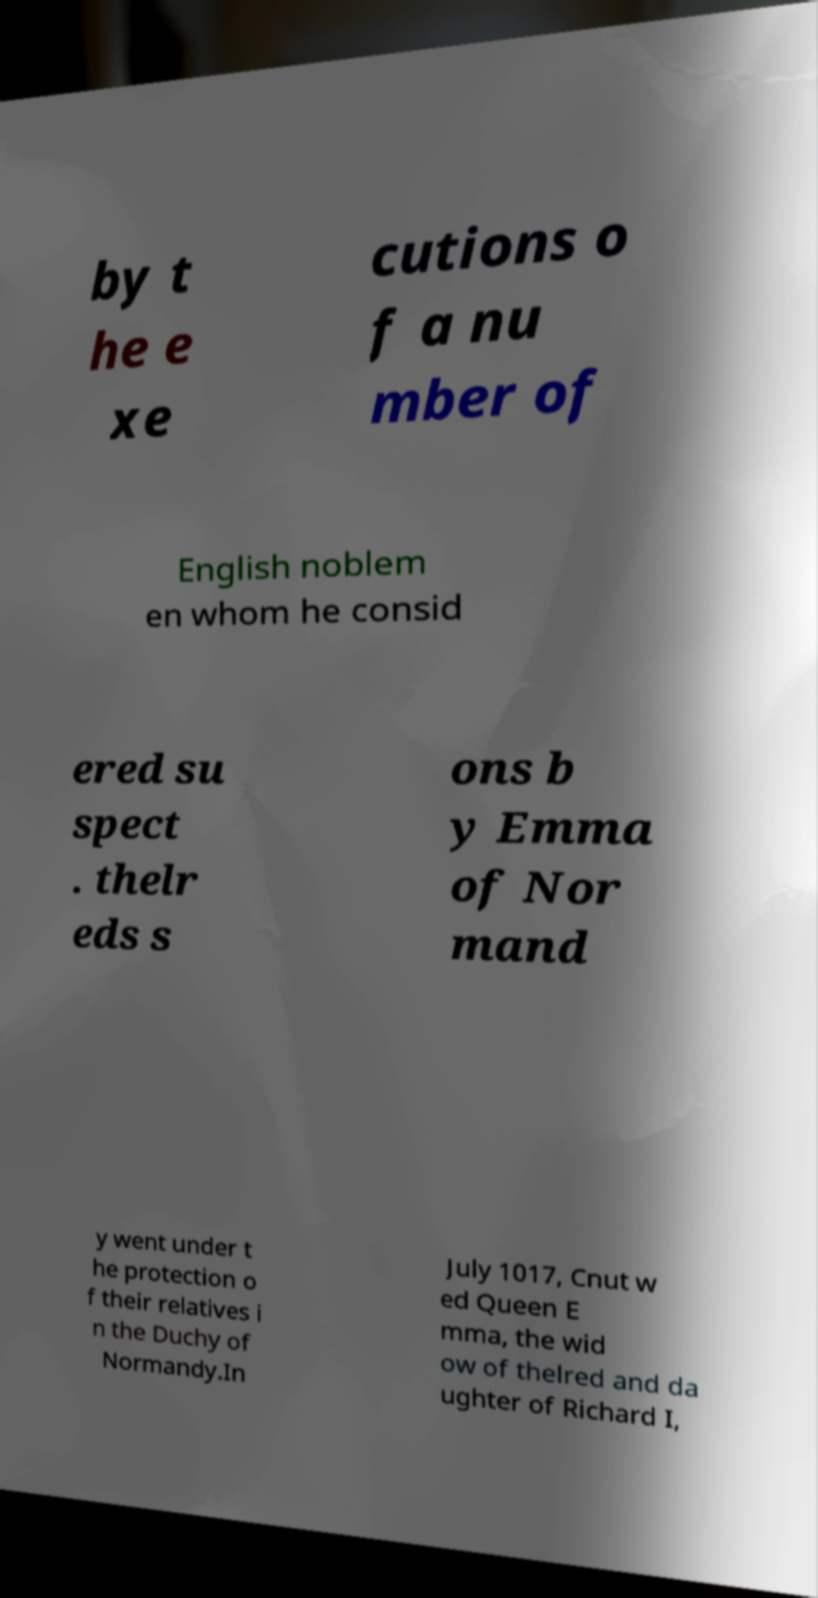I need the written content from this picture converted into text. Can you do that? by t he e xe cutions o f a nu mber of English noblem en whom he consid ered su spect . thelr eds s ons b y Emma of Nor mand y went under t he protection o f their relatives i n the Duchy of Normandy.In July 1017, Cnut w ed Queen E mma, the wid ow of thelred and da ughter of Richard I, 